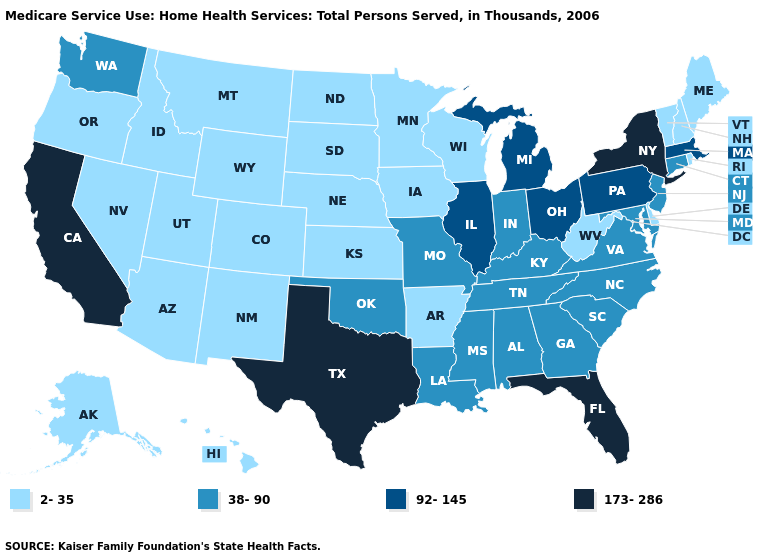Does California have the highest value in the West?
Answer briefly. Yes. What is the value of Ohio?
Concise answer only. 92-145. Among the states that border Rhode Island , does Connecticut have the lowest value?
Short answer required. Yes. Does North Dakota have the same value as Maryland?
Short answer required. No. Which states have the highest value in the USA?
Quick response, please. California, Florida, New York, Texas. What is the value of Massachusetts?
Quick response, please. 92-145. Among the states that border Oregon , which have the highest value?
Write a very short answer. California. Does Florida have the highest value in the USA?
Be succinct. Yes. Name the states that have a value in the range 38-90?
Be succinct. Alabama, Connecticut, Georgia, Indiana, Kentucky, Louisiana, Maryland, Mississippi, Missouri, New Jersey, North Carolina, Oklahoma, South Carolina, Tennessee, Virginia, Washington. Does Oklahoma have the lowest value in the USA?
Quick response, please. No. What is the value of Tennessee?
Concise answer only. 38-90. Among the states that border South Dakota , which have the lowest value?
Give a very brief answer. Iowa, Minnesota, Montana, Nebraska, North Dakota, Wyoming. What is the lowest value in the MidWest?
Short answer required. 2-35. What is the value of Connecticut?
Concise answer only. 38-90. What is the value of Missouri?
Answer briefly. 38-90. 